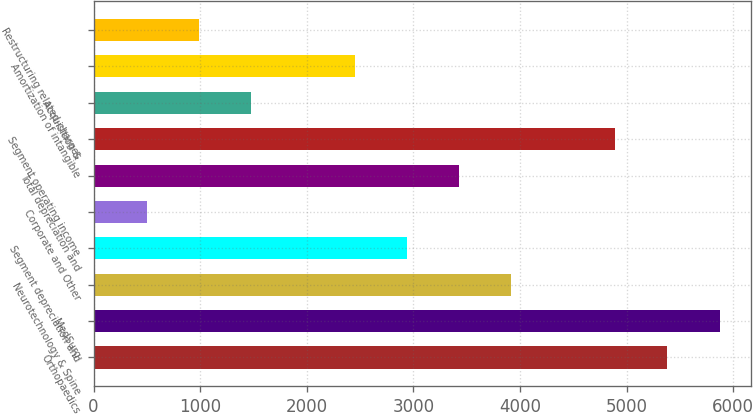Convert chart to OTSL. <chart><loc_0><loc_0><loc_500><loc_500><bar_chart><fcel>Orthopaedics<fcel>MedSurg<fcel>Neurotechnology & Spine<fcel>Segment depreciation and<fcel>Corporate and Other<fcel>Total depreciation and<fcel>Segment operating income<fcel>Acquisition &<fcel>Amortization of intangible<fcel>Restructuring related-charges<nl><fcel>5382.2<fcel>5870.4<fcel>3917.6<fcel>2941.2<fcel>500.2<fcel>3429.4<fcel>4894<fcel>1476.6<fcel>2453<fcel>988.4<nl></chart> 